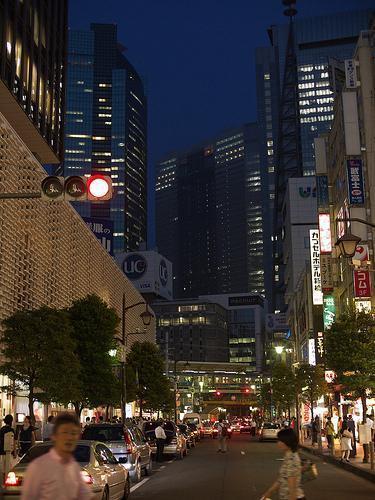How many red lights are there?
Give a very brief answer. 3. How many lights does the stoplight have?
Give a very brief answer. 3. 